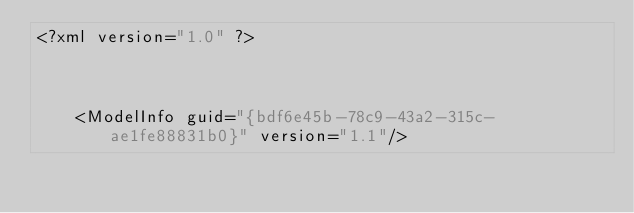<code> <loc_0><loc_0><loc_500><loc_500><_XML_><?xml version="1.0" ?>

	<ModelInfo guid="{bdf6e45b-78c9-43a2-315c-ae1fe88831b0}" version="1.1"/>
</code> 